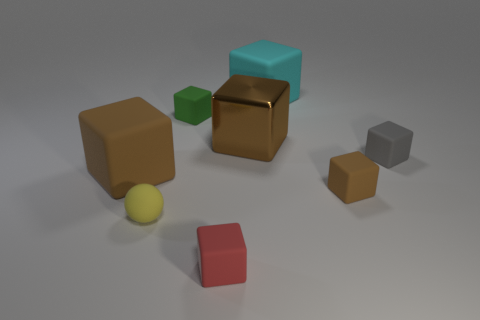How many brown cubes must be subtracted to get 1 brown cubes? 2 Subtract all green cylinders. How many brown blocks are left? 3 Subtract all small red cubes. How many cubes are left? 6 Subtract all gray cubes. How many cubes are left? 6 Subtract all purple cubes. Subtract all cyan spheres. How many cubes are left? 7 Add 2 large cyan blocks. How many objects exist? 10 Subtract all blocks. How many objects are left? 1 Subtract all purple metal balls. Subtract all big shiny objects. How many objects are left? 7 Add 8 big brown shiny objects. How many big brown shiny objects are left? 9 Add 8 large purple matte objects. How many large purple matte objects exist? 8 